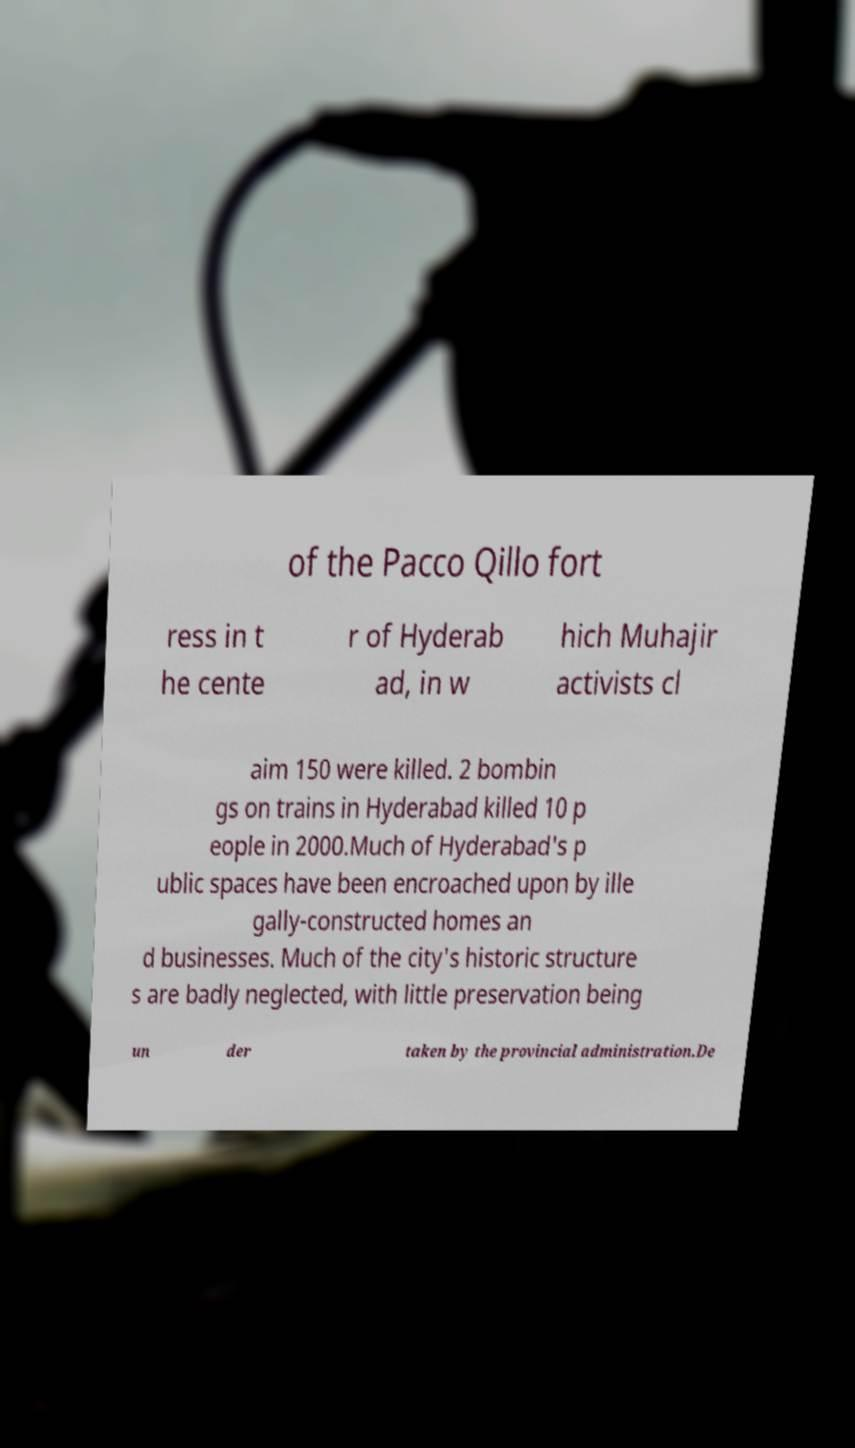For documentation purposes, I need the text within this image transcribed. Could you provide that? of the Pacco Qillo fort ress in t he cente r of Hyderab ad, in w hich Muhajir activists cl aim 150 were killed. 2 bombin gs on trains in Hyderabad killed 10 p eople in 2000.Much of Hyderabad's p ublic spaces have been encroached upon by ille gally-constructed homes an d businesses. Much of the city's historic structure s are badly neglected, with little preservation being un der taken by the provincial administration.De 